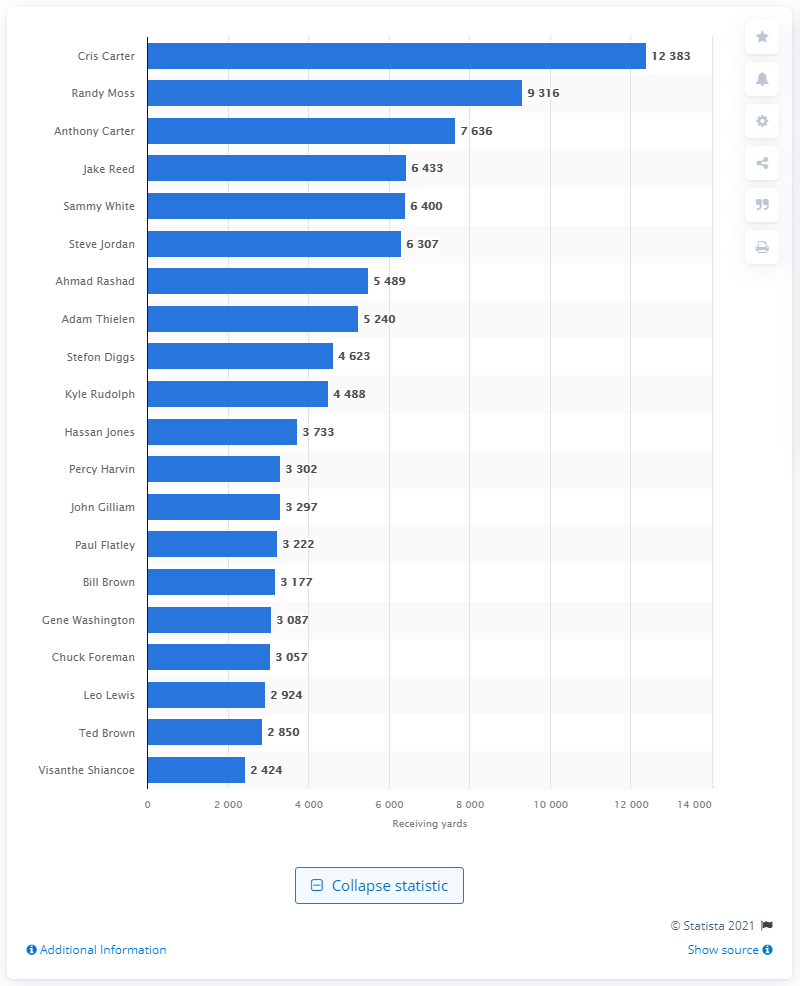Specify some key components in this picture. Cris Carter is the career receiving leader of the Minnesota Vikings. 